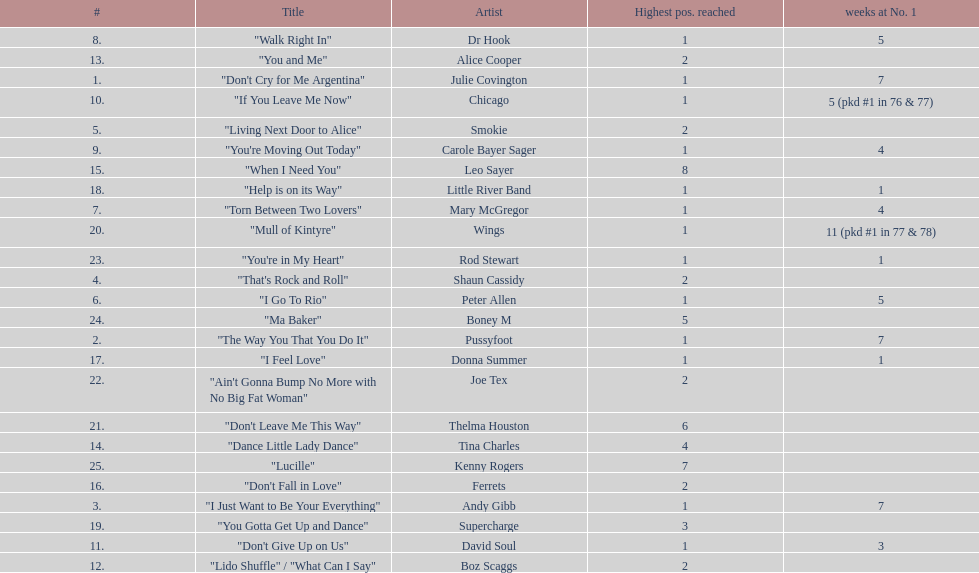What was the number of weeks that julie covington's single " don't cry for me argentinia," was at number 1 in 1977? 7. 